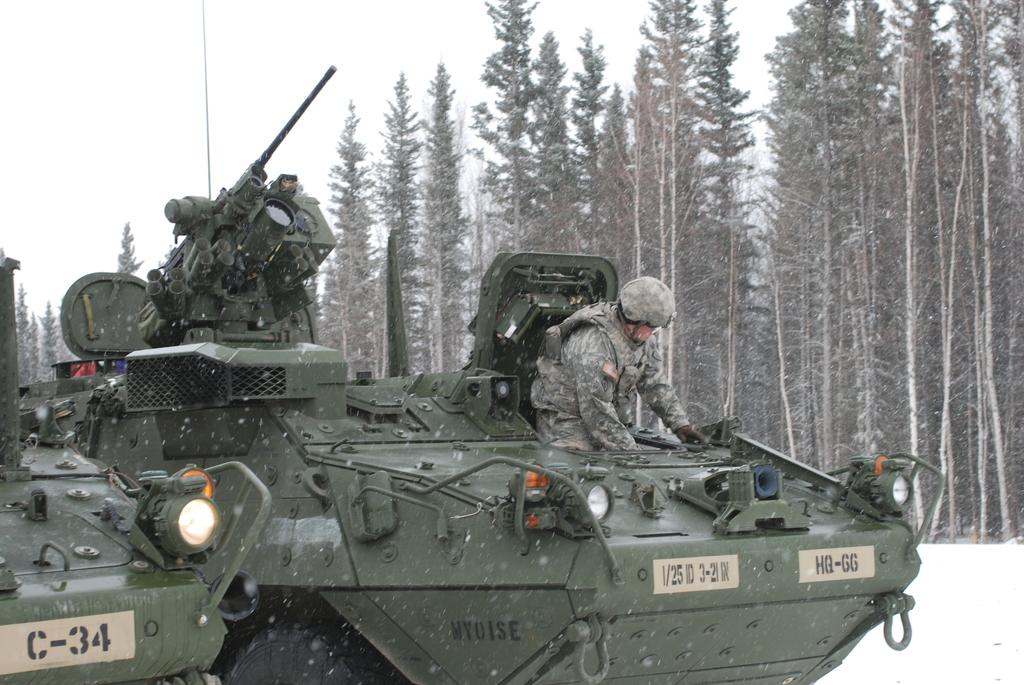What is the main subject of the image? The main subject of the image is an army tanker. Can you describe the person in the image? There is a man standing above the tanker. What is the condition of the land in the image? The land is covered with snow. What can be seen in the background of the image? There are trees in the background of the image. What is visible in the sky in the image? The sky is visible in the image. What type of root can be seen growing from the tanker in the image? There are no roots visible in the image, as it features an army tanker and a man standing above it on snow-covered land. 